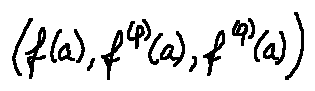Convert formula to latex. <formula><loc_0><loc_0><loc_500><loc_500>( f ( a ) , f ^ { ( p ) } ( a ) , f ^ { ( q ) } ( a ) )</formula> 